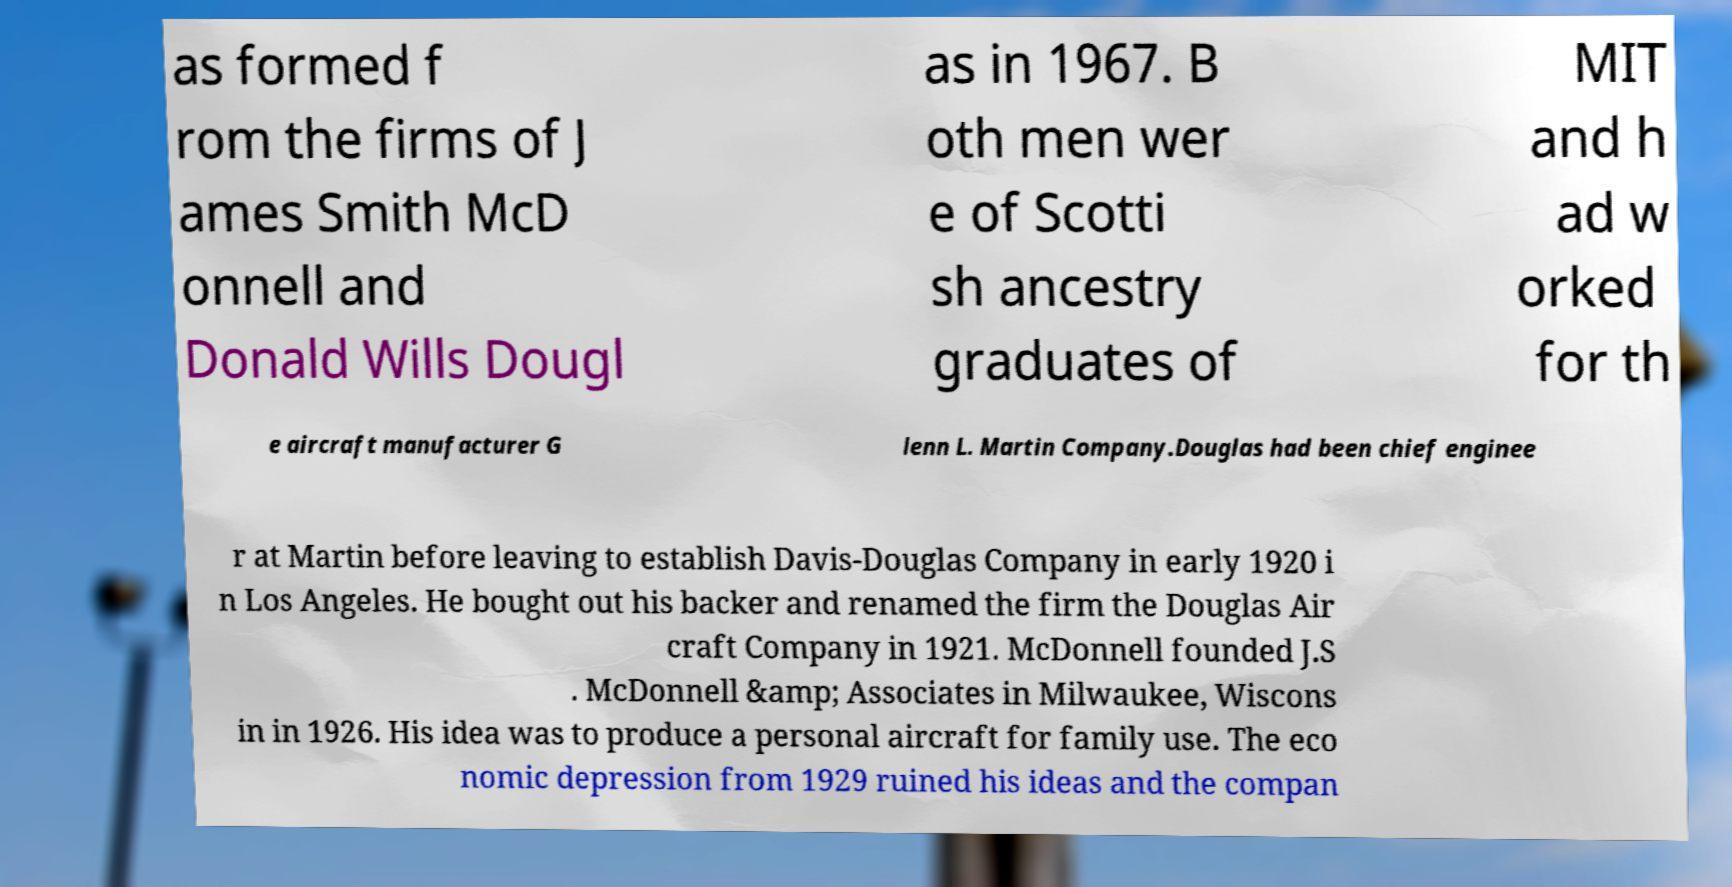Could you extract and type out the text from this image? as formed f rom the firms of J ames Smith McD onnell and Donald Wills Dougl as in 1967. B oth men wer e of Scotti sh ancestry graduates of MIT and h ad w orked for th e aircraft manufacturer G lenn L. Martin Company.Douglas had been chief enginee r at Martin before leaving to establish Davis-Douglas Company in early 1920 i n Los Angeles. He bought out his backer and renamed the firm the Douglas Air craft Company in 1921. McDonnell founded J.S . McDonnell &amp; Associates in Milwaukee, Wiscons in in 1926. His idea was to produce a personal aircraft for family use. The eco nomic depression from 1929 ruined his ideas and the compan 